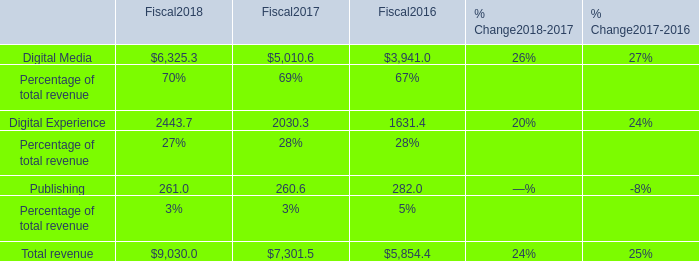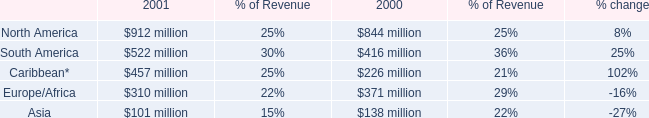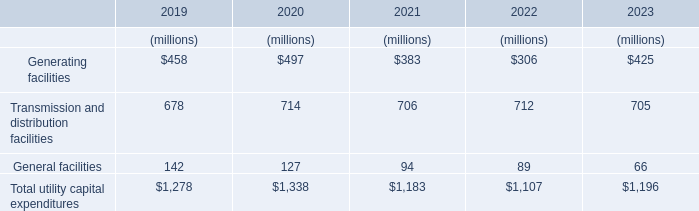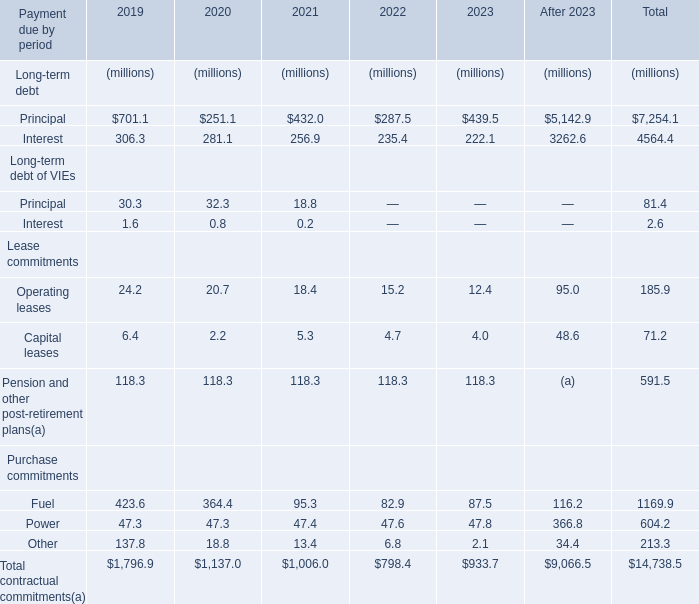What is the growing rate of Fuel in the year with the most Power? 
Computations: ((87.5 - 82.9) / 82.9)
Answer: 0.05549. 